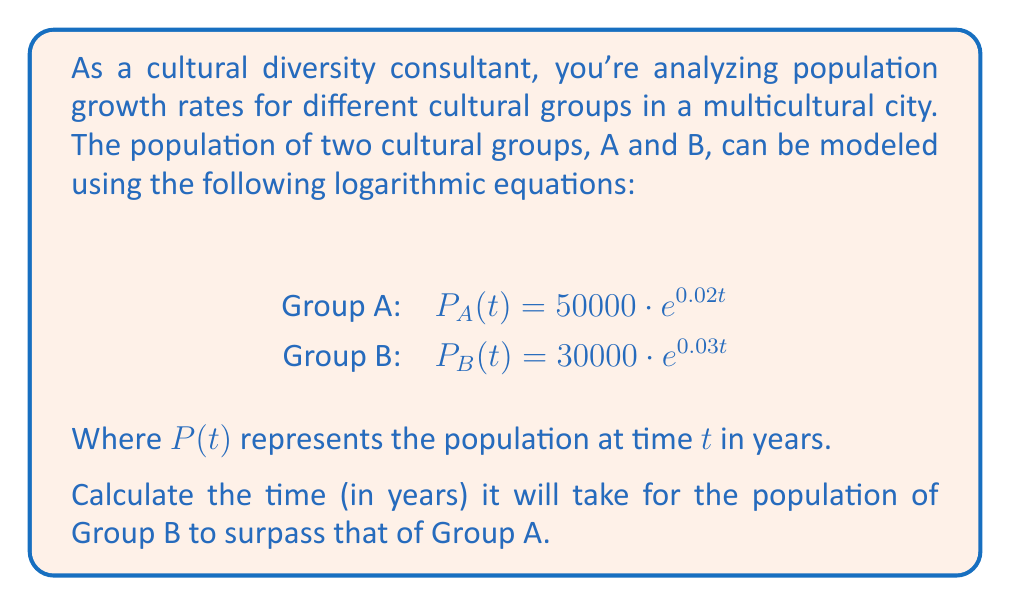Solve this math problem. To solve this problem, we need to find the time $t$ when the populations of Group A and Group B are equal. After that point, Group B's population will surpass Group A's.

1) Set up the equation:
   $P_A(t) = P_B(t)$
   $50000 \cdot e^{0.02t} = 30000 \cdot e^{0.03t}$

2) Divide both sides by 30000:
   $\frac{5}{3} \cdot e^{0.02t} = e^{0.03t}$

3) Take the natural logarithm of both sides:
   $\ln(\frac{5}{3}) + 0.02t = 0.03t$

4) Subtract 0.02t from both sides:
   $\ln(\frac{5}{3}) = 0.01t$

5) Divide both sides by 0.01:
   $t = \frac{\ln(\frac{5}{3})}{0.01}$

6) Calculate the result:
   $t \approx 51.08$ years

Therefore, it will take approximately 51.08 years for the population of Group B to surpass that of Group A.
Answer: $51.08$ years 